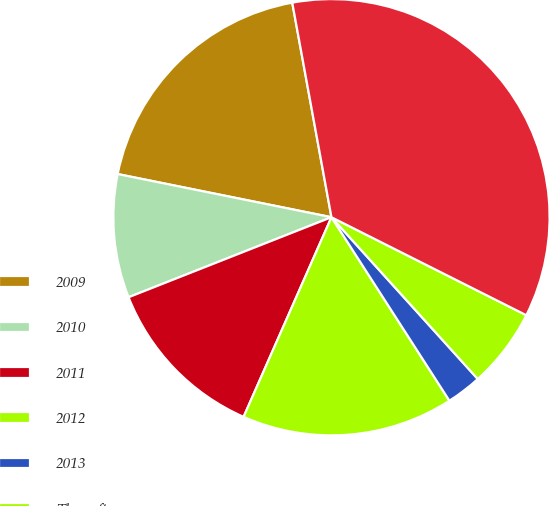<chart> <loc_0><loc_0><loc_500><loc_500><pie_chart><fcel>2009<fcel>2010<fcel>2011<fcel>2012<fcel>2013<fcel>Thereafter<fcel>Total<nl><fcel>18.95%<fcel>9.15%<fcel>12.42%<fcel>15.69%<fcel>2.61%<fcel>5.88%<fcel>35.29%<nl></chart> 